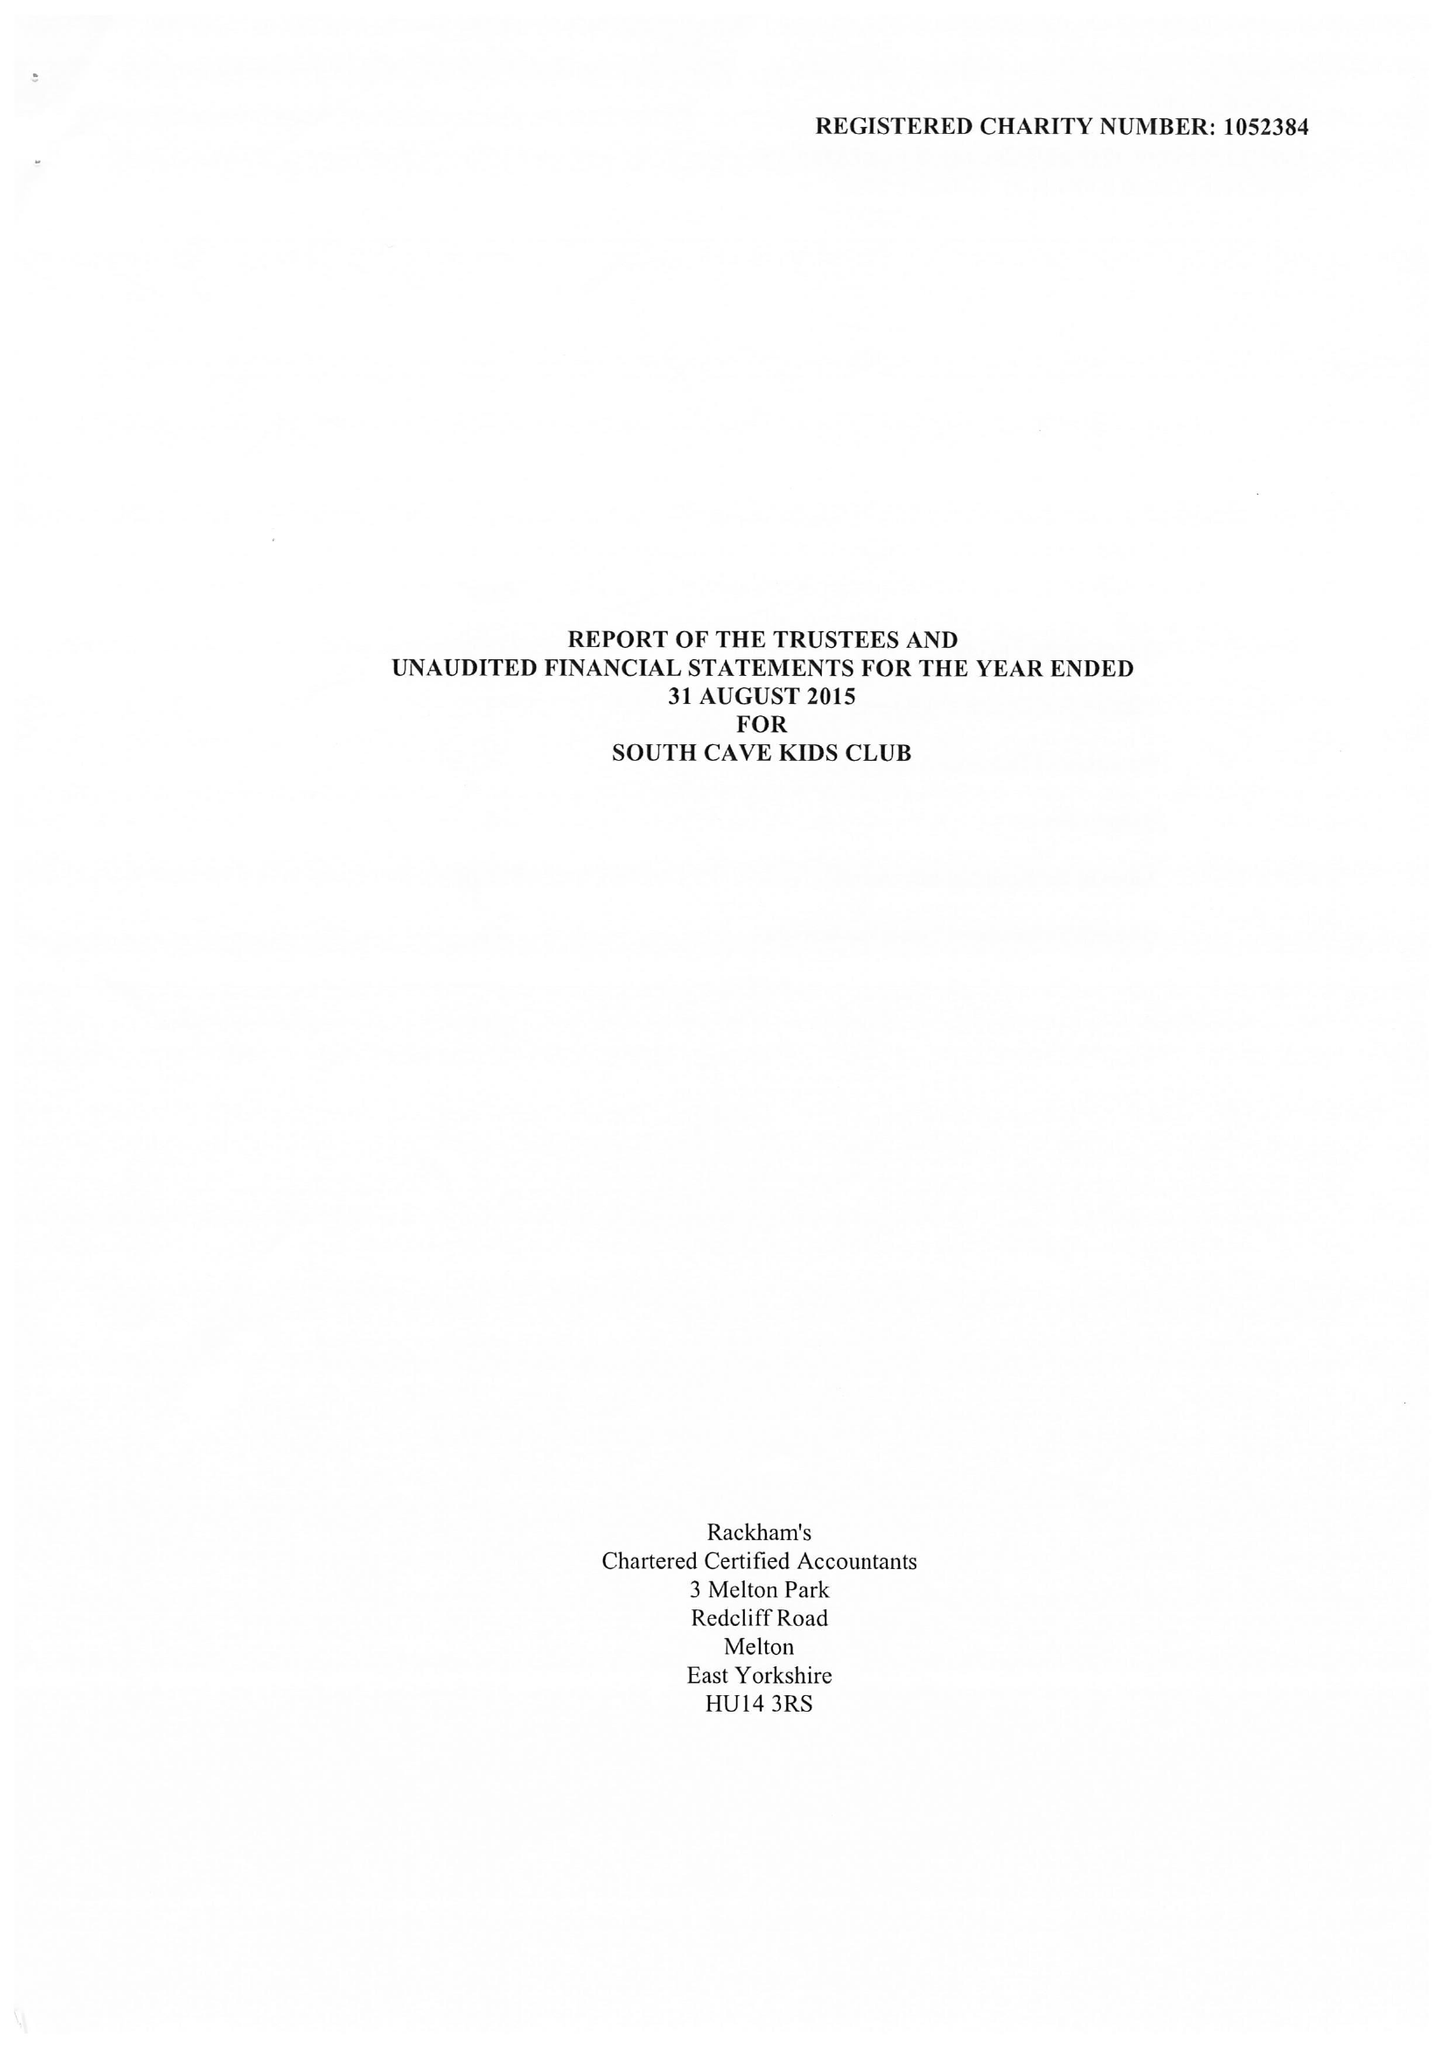What is the value for the address__post_town?
Answer the question using a single word or phrase. BROUGH 